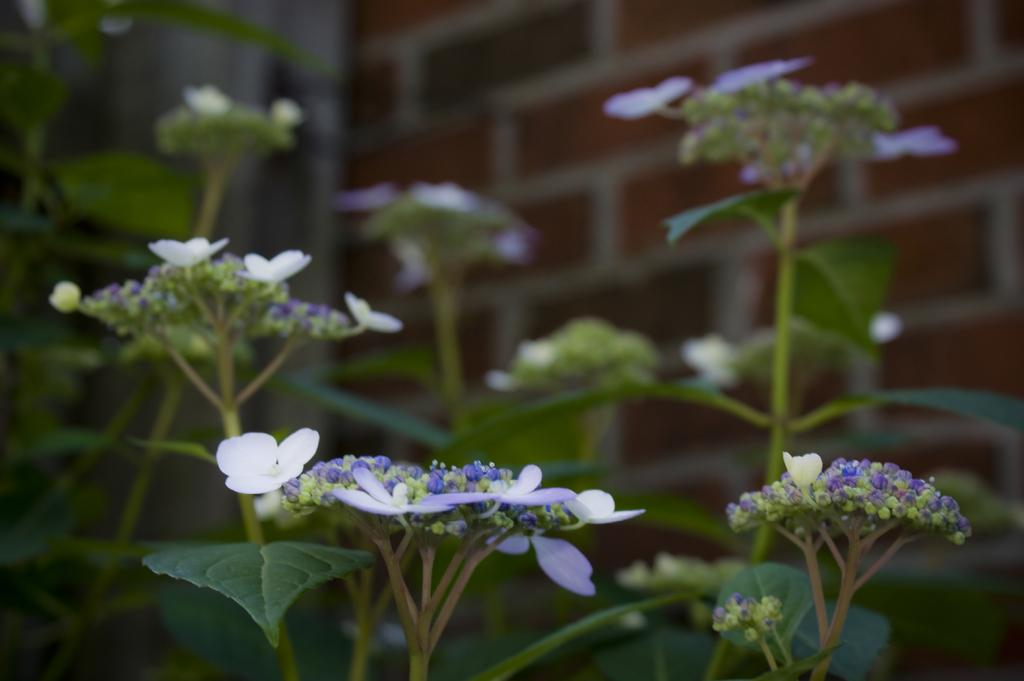What type of plants can be seen in the image? There are flower plants in the image. What is visible in the background of the image? There is a brick wall in the background of the image. What type of wool can be seen on the flower plants in the image? There is no wool present on the flower plants in the image. 